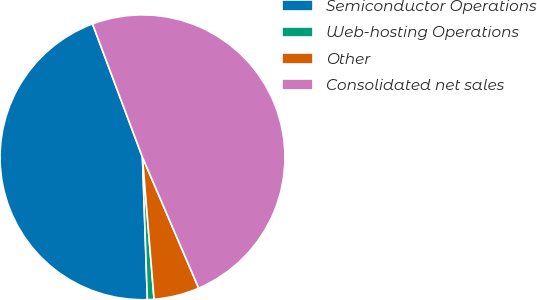Convert chart. <chart><loc_0><loc_0><loc_500><loc_500><pie_chart><fcel>Semiconductor Operations<fcel>Web-hosting Operations<fcel>Other<fcel>Consolidated net sales<nl><fcel>44.84%<fcel>0.75%<fcel>5.16%<fcel>49.25%<nl></chart> 